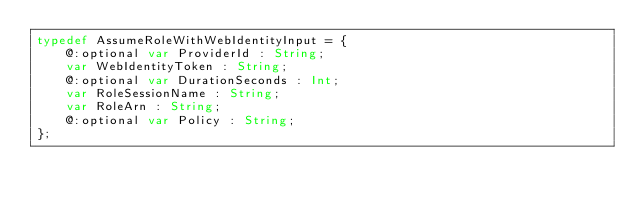Convert code to text. <code><loc_0><loc_0><loc_500><loc_500><_Haxe_>typedef AssumeRoleWithWebIdentityInput = {
    @:optional var ProviderId : String;
    var WebIdentityToken : String;
    @:optional var DurationSeconds : Int;
    var RoleSessionName : String;
    var RoleArn : String;
    @:optional var Policy : String;
};
</code> 